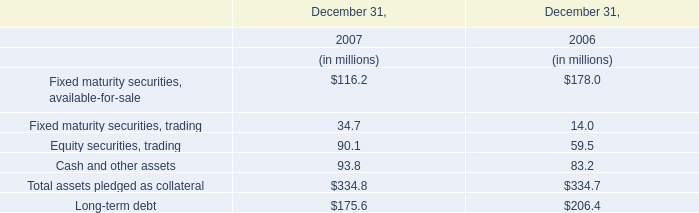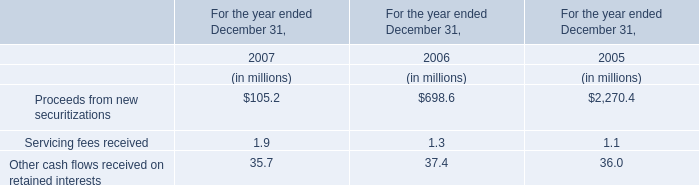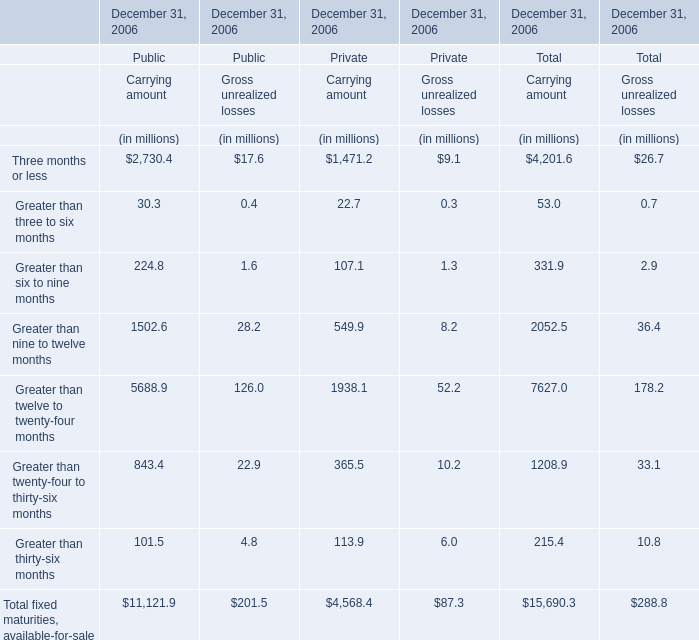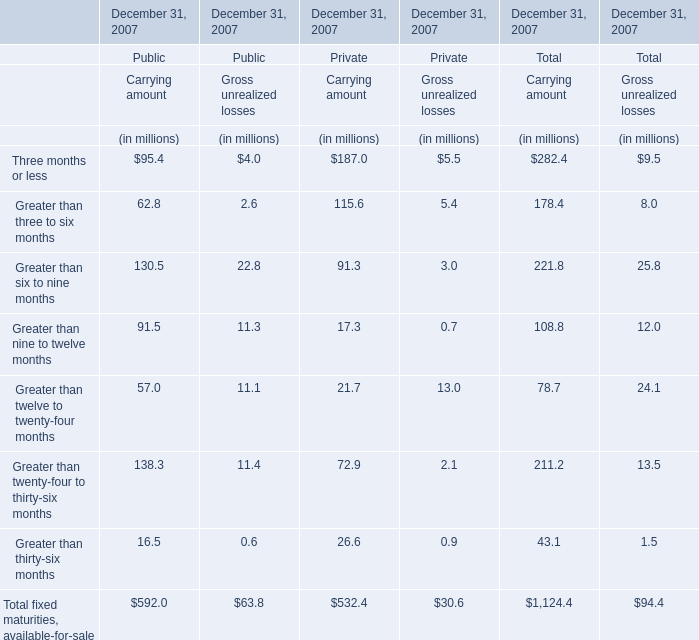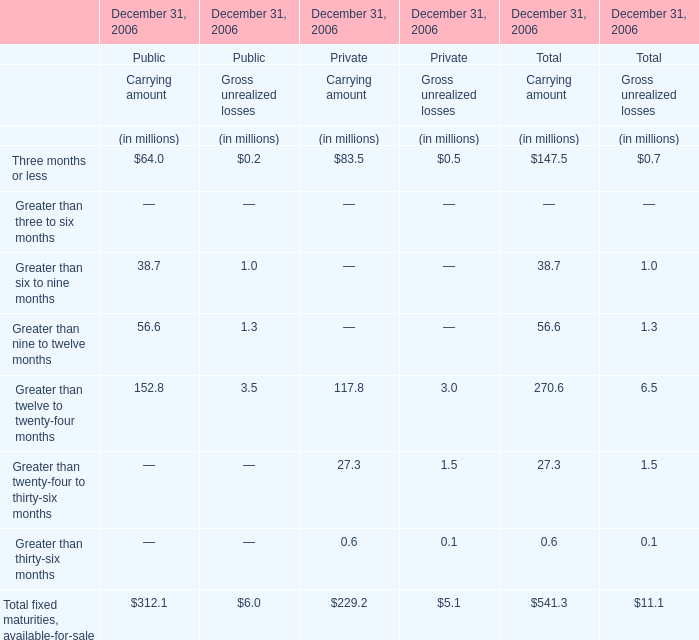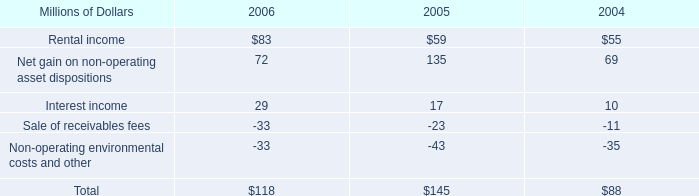What's the total amount of the Carrying amount in the year where Greater than three to six months greater than 0 for Total for Carrying amount? (in million) 
Computations: ((((((282.4 + 178.4) + 221.8) + 108.8) + 211.2) + 78.7) + 43.1)
Answer: 1124.4. 